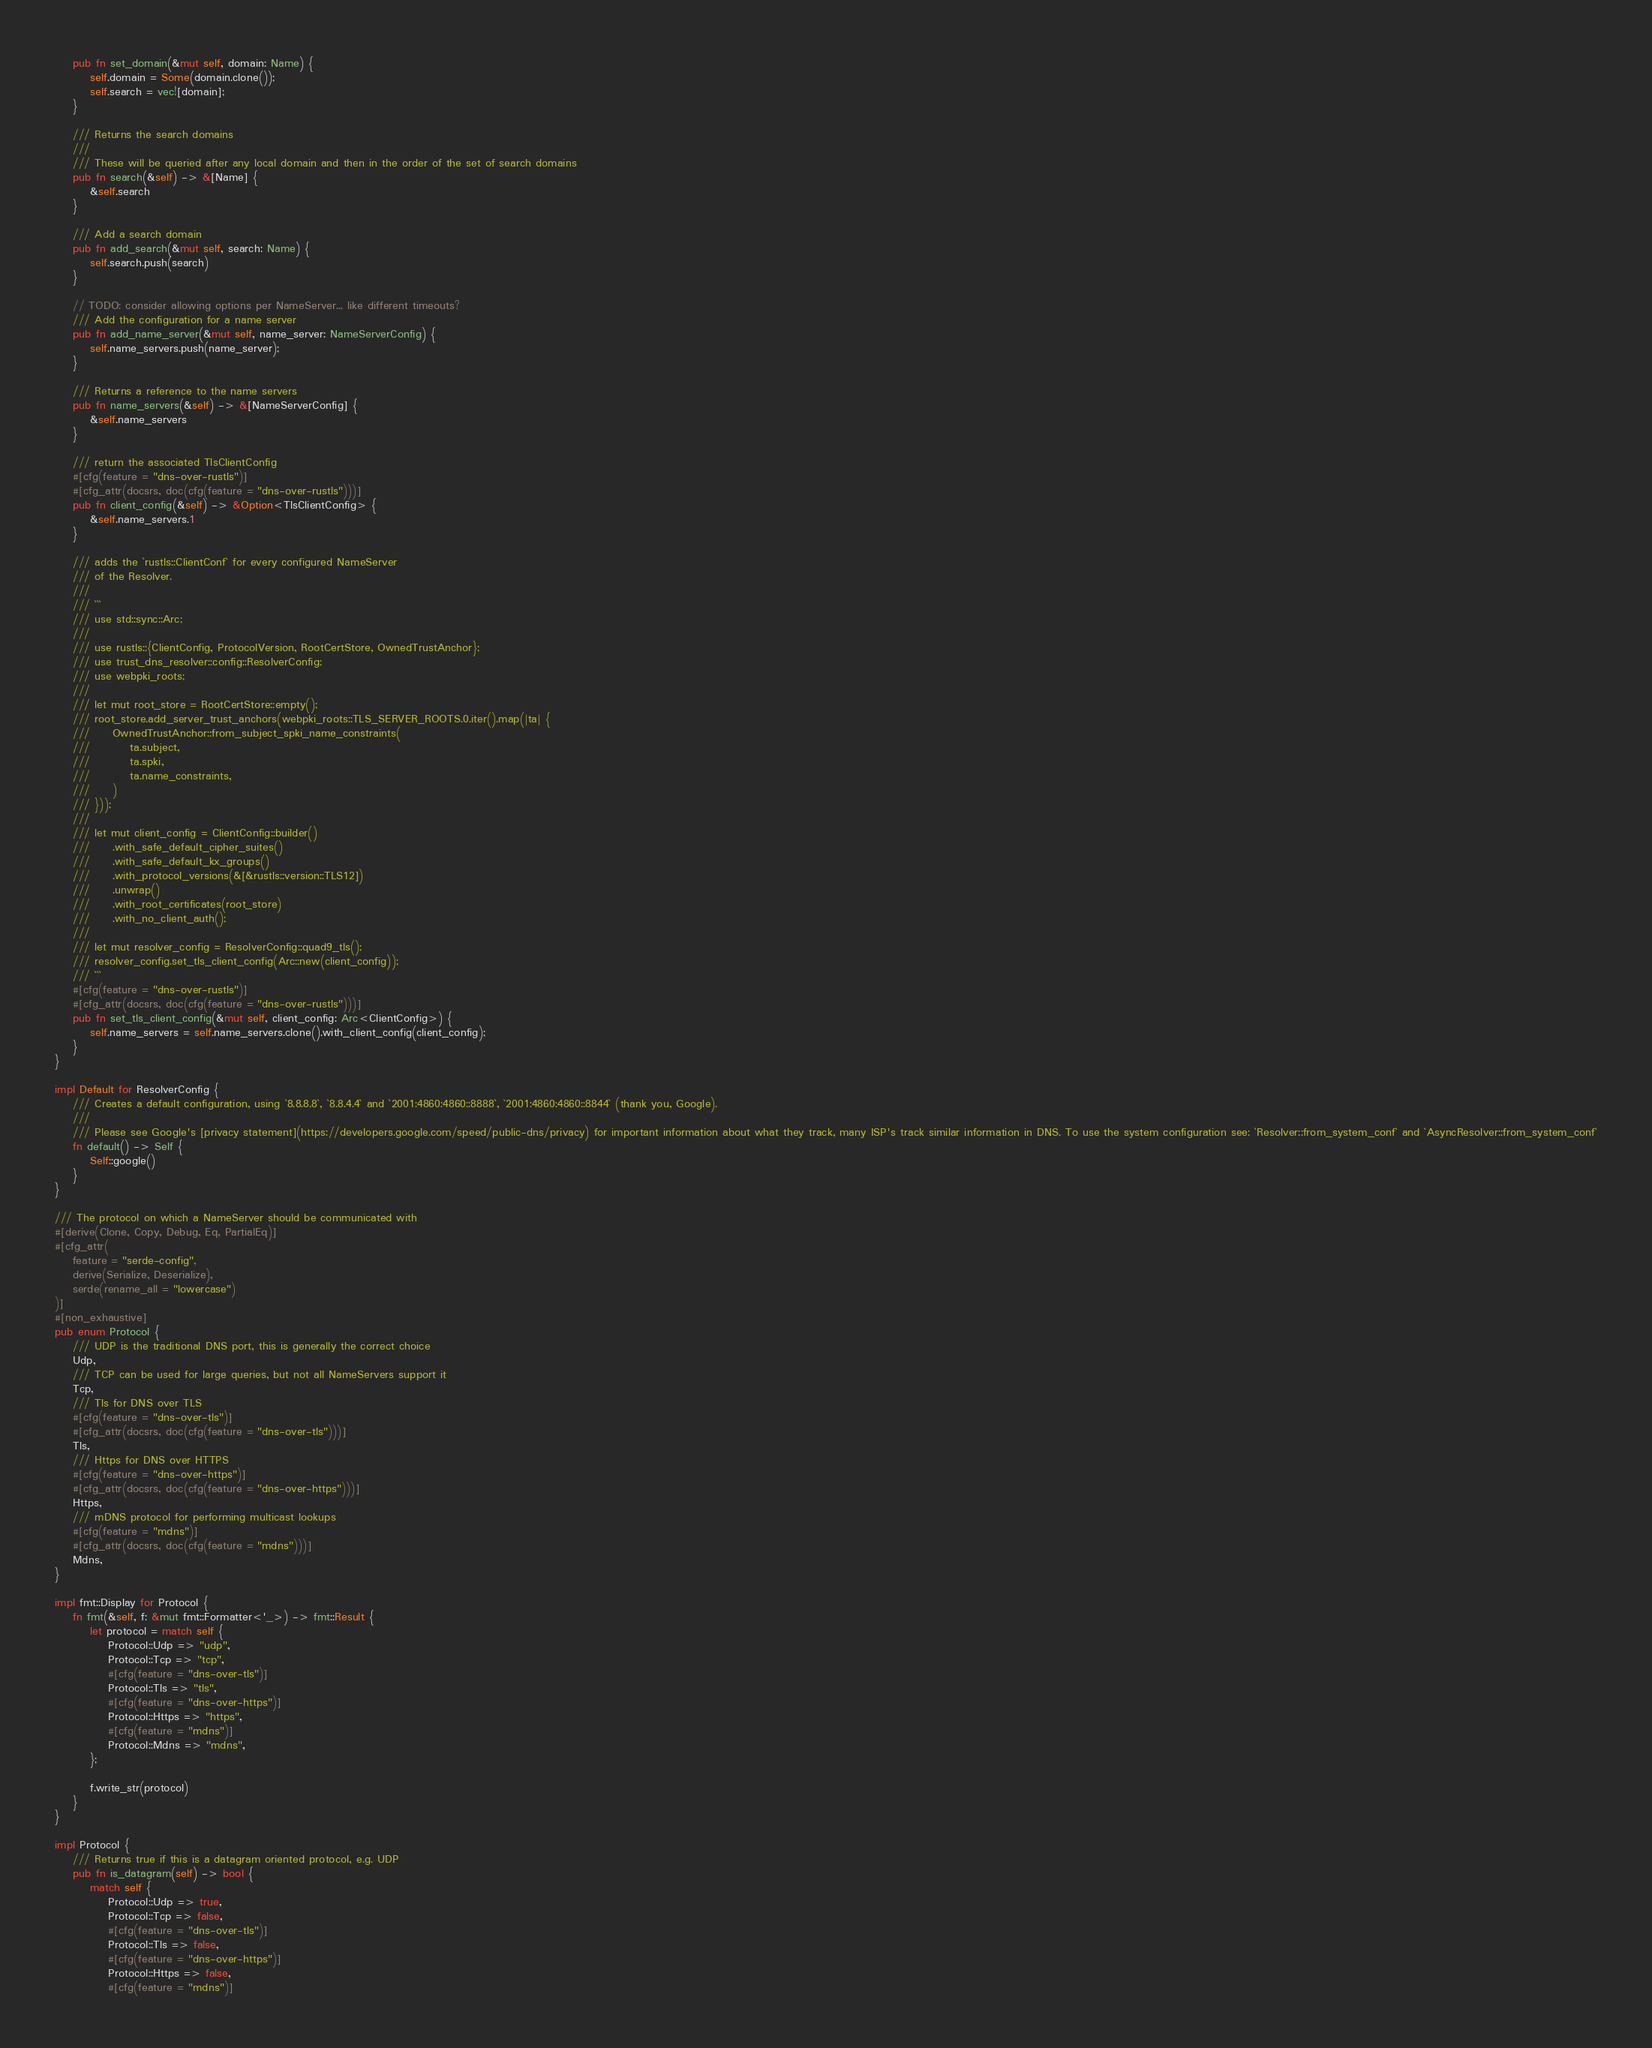<code> <loc_0><loc_0><loc_500><loc_500><_Rust_>    pub fn set_domain(&mut self, domain: Name) {
        self.domain = Some(domain.clone());
        self.search = vec![domain];
    }

    /// Returns the search domains
    ///
    /// These will be queried after any local domain and then in the order of the set of search domains
    pub fn search(&self) -> &[Name] {
        &self.search
    }

    /// Add a search domain
    pub fn add_search(&mut self, search: Name) {
        self.search.push(search)
    }

    // TODO: consider allowing options per NameServer... like different timeouts?
    /// Add the configuration for a name server
    pub fn add_name_server(&mut self, name_server: NameServerConfig) {
        self.name_servers.push(name_server);
    }

    /// Returns a reference to the name servers
    pub fn name_servers(&self) -> &[NameServerConfig] {
        &self.name_servers
    }

    /// return the associated TlsClientConfig
    #[cfg(feature = "dns-over-rustls")]
    #[cfg_attr(docsrs, doc(cfg(feature = "dns-over-rustls")))]
    pub fn client_config(&self) -> &Option<TlsClientConfig> {
        &self.name_servers.1
    }

    /// adds the `rustls::ClientConf` for every configured NameServer
    /// of the Resolver.
    ///
    /// ```
    /// use std::sync::Arc;
    ///
    /// use rustls::{ClientConfig, ProtocolVersion, RootCertStore, OwnedTrustAnchor};
    /// use trust_dns_resolver::config::ResolverConfig;
    /// use webpki_roots;
    ///
    /// let mut root_store = RootCertStore::empty();
    /// root_store.add_server_trust_anchors(webpki_roots::TLS_SERVER_ROOTS.0.iter().map(|ta| {
    ///     OwnedTrustAnchor::from_subject_spki_name_constraints(
    ///         ta.subject,
    ///         ta.spki,
    ///         ta.name_constraints,
    ///     )
    /// }));
    ///
    /// let mut client_config = ClientConfig::builder()
    ///     .with_safe_default_cipher_suites()
    ///     .with_safe_default_kx_groups()
    ///     .with_protocol_versions(&[&rustls::version::TLS12])
    ///     .unwrap()
    ///     .with_root_certificates(root_store)
    ///     .with_no_client_auth();
    ///
    /// let mut resolver_config = ResolverConfig::quad9_tls();
    /// resolver_config.set_tls_client_config(Arc::new(client_config));
    /// ```
    #[cfg(feature = "dns-over-rustls")]
    #[cfg_attr(docsrs, doc(cfg(feature = "dns-over-rustls")))]
    pub fn set_tls_client_config(&mut self, client_config: Arc<ClientConfig>) {
        self.name_servers = self.name_servers.clone().with_client_config(client_config);
    }
}

impl Default for ResolverConfig {
    /// Creates a default configuration, using `8.8.8.8`, `8.8.4.4` and `2001:4860:4860::8888`, `2001:4860:4860::8844` (thank you, Google).
    ///
    /// Please see Google's [privacy statement](https://developers.google.com/speed/public-dns/privacy) for important information about what they track, many ISP's track similar information in DNS. To use the system configuration see: `Resolver::from_system_conf` and `AsyncResolver::from_system_conf`
    fn default() -> Self {
        Self::google()
    }
}

/// The protocol on which a NameServer should be communicated with
#[derive(Clone, Copy, Debug, Eq, PartialEq)]
#[cfg_attr(
    feature = "serde-config",
    derive(Serialize, Deserialize),
    serde(rename_all = "lowercase")
)]
#[non_exhaustive]
pub enum Protocol {
    /// UDP is the traditional DNS port, this is generally the correct choice
    Udp,
    /// TCP can be used for large queries, but not all NameServers support it
    Tcp,
    /// Tls for DNS over TLS
    #[cfg(feature = "dns-over-tls")]
    #[cfg_attr(docsrs, doc(cfg(feature = "dns-over-tls")))]
    Tls,
    /// Https for DNS over HTTPS
    #[cfg(feature = "dns-over-https")]
    #[cfg_attr(docsrs, doc(cfg(feature = "dns-over-https")))]
    Https,
    /// mDNS protocol for performing multicast lookups
    #[cfg(feature = "mdns")]
    #[cfg_attr(docsrs, doc(cfg(feature = "mdns")))]
    Mdns,
}

impl fmt::Display for Protocol {
    fn fmt(&self, f: &mut fmt::Formatter<'_>) -> fmt::Result {
        let protocol = match self {
            Protocol::Udp => "udp",
            Protocol::Tcp => "tcp",
            #[cfg(feature = "dns-over-tls")]
            Protocol::Tls => "tls",
            #[cfg(feature = "dns-over-https")]
            Protocol::Https => "https",
            #[cfg(feature = "mdns")]
            Protocol::Mdns => "mdns",
        };

        f.write_str(protocol)
    }
}

impl Protocol {
    /// Returns true if this is a datagram oriented protocol, e.g. UDP
    pub fn is_datagram(self) -> bool {
        match self {
            Protocol::Udp => true,
            Protocol::Tcp => false,
            #[cfg(feature = "dns-over-tls")]
            Protocol::Tls => false,
            #[cfg(feature = "dns-over-https")]
            Protocol::Https => false,
            #[cfg(feature = "mdns")]</code> 